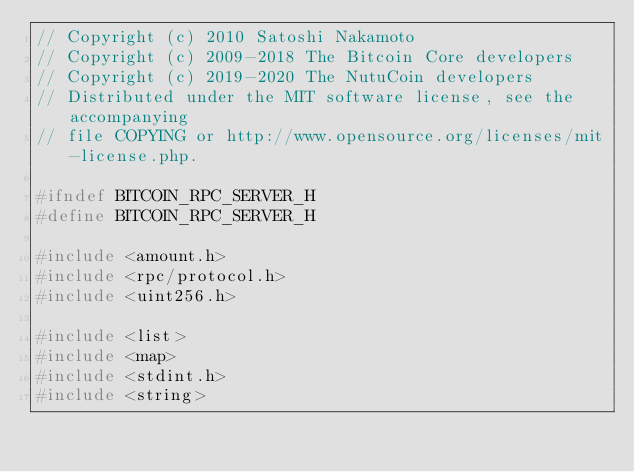<code> <loc_0><loc_0><loc_500><loc_500><_C_>// Copyright (c) 2010 Satoshi Nakamoto
// Copyright (c) 2009-2018 The Bitcoin Core developers
// Copyright (c) 2019-2020 The NutuCoin developers 
// Distributed under the MIT software license, see the accompanying
// file COPYING or http://www.opensource.org/licenses/mit-license.php.

#ifndef BITCOIN_RPC_SERVER_H
#define BITCOIN_RPC_SERVER_H

#include <amount.h>
#include <rpc/protocol.h>
#include <uint256.h>

#include <list>
#include <map>
#include <stdint.h>
#include <string>
</code> 